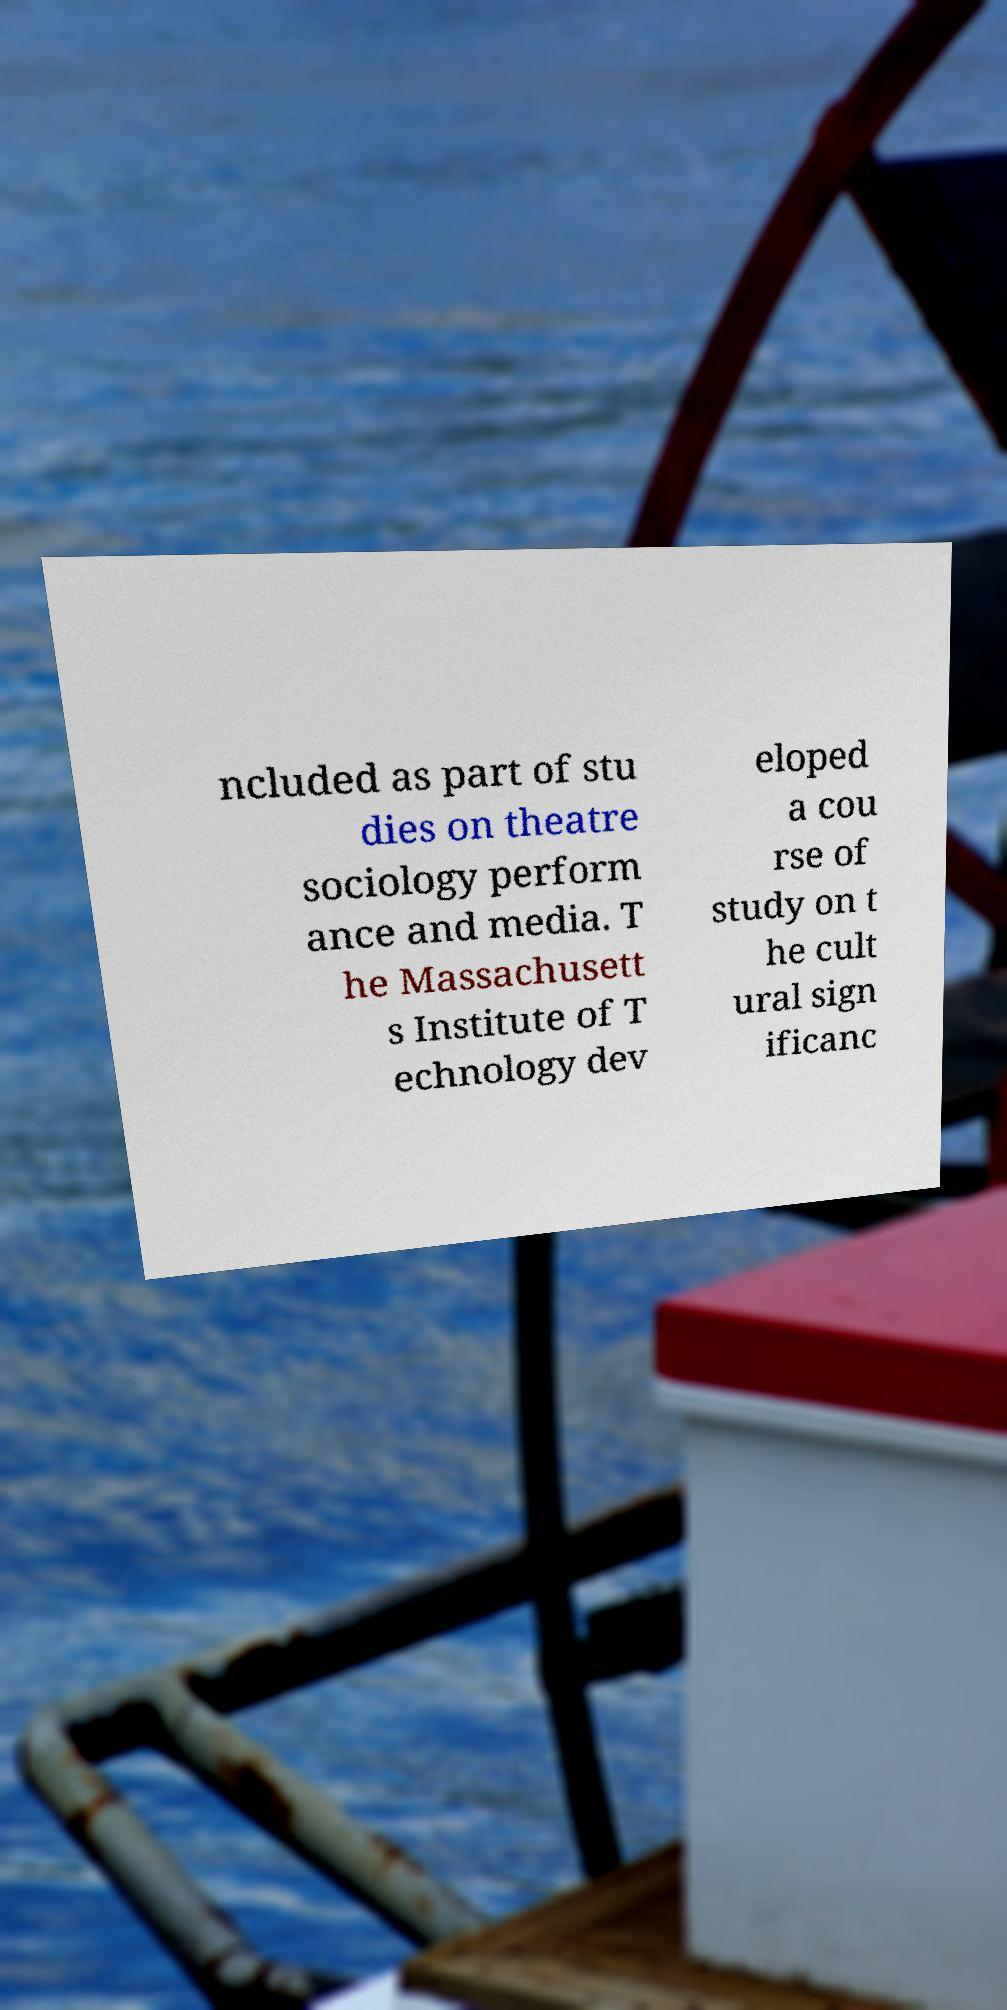Please identify and transcribe the text found in this image. ncluded as part of stu dies on theatre sociology perform ance and media. T he Massachusett s Institute of T echnology dev eloped a cou rse of study on t he cult ural sign ificanc 